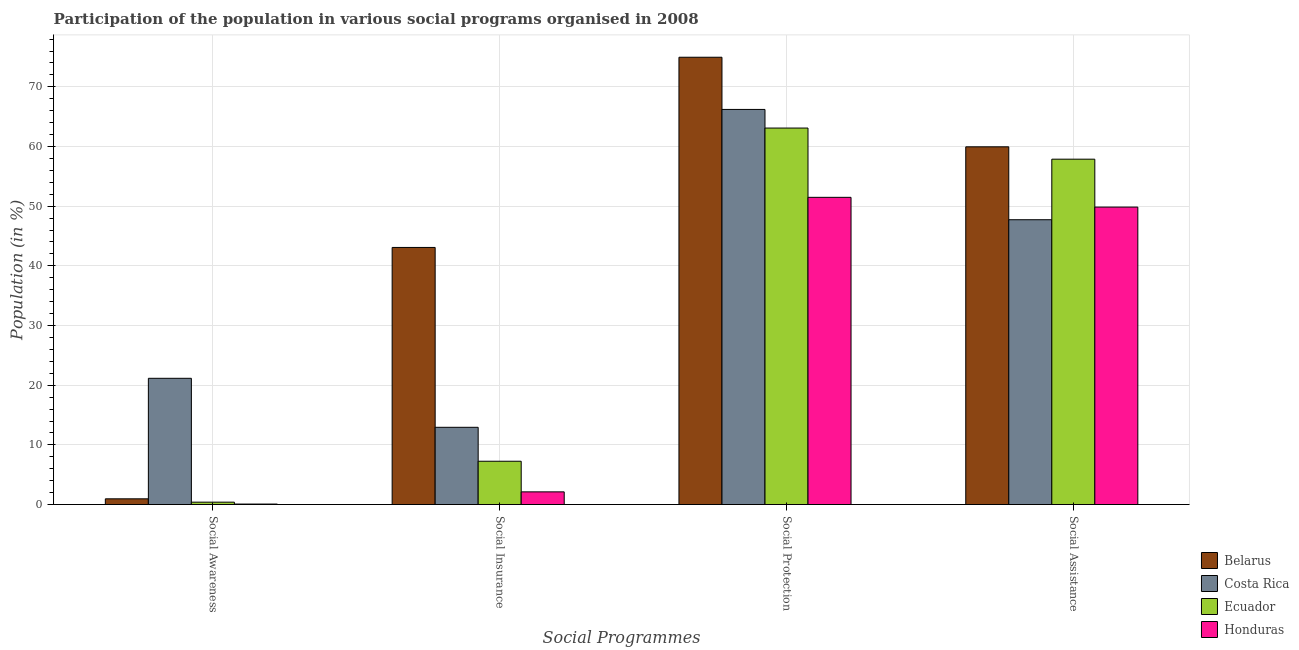Are the number of bars per tick equal to the number of legend labels?
Give a very brief answer. Yes. What is the label of the 3rd group of bars from the left?
Provide a succinct answer. Social Protection. What is the participation of population in social protection programs in Costa Rica?
Give a very brief answer. 66.22. Across all countries, what is the maximum participation of population in social assistance programs?
Your answer should be compact. 59.95. Across all countries, what is the minimum participation of population in social awareness programs?
Make the answer very short. 0.08. In which country was the participation of population in social awareness programs maximum?
Your answer should be compact. Costa Rica. What is the total participation of population in social awareness programs in the graph?
Make the answer very short. 22.59. What is the difference between the participation of population in social assistance programs in Belarus and that in Costa Rica?
Offer a very short reply. 12.22. What is the difference between the participation of population in social protection programs in Ecuador and the participation of population in social insurance programs in Honduras?
Ensure brevity in your answer.  60.97. What is the average participation of population in social protection programs per country?
Offer a terse response. 63.94. What is the difference between the participation of population in social awareness programs and participation of population in social insurance programs in Costa Rica?
Provide a succinct answer. 8.21. In how many countries, is the participation of population in social assistance programs greater than 30 %?
Ensure brevity in your answer.  4. What is the ratio of the participation of population in social insurance programs in Belarus to that in Costa Rica?
Your answer should be compact. 3.33. Is the difference between the participation of population in social protection programs in Ecuador and Costa Rica greater than the difference between the participation of population in social insurance programs in Ecuador and Costa Rica?
Provide a short and direct response. Yes. What is the difference between the highest and the second highest participation of population in social assistance programs?
Your answer should be compact. 2.07. What is the difference between the highest and the lowest participation of population in social insurance programs?
Ensure brevity in your answer.  40.96. In how many countries, is the participation of population in social awareness programs greater than the average participation of population in social awareness programs taken over all countries?
Offer a very short reply. 1. Is it the case that in every country, the sum of the participation of population in social assistance programs and participation of population in social insurance programs is greater than the sum of participation of population in social awareness programs and participation of population in social protection programs?
Give a very brief answer. Yes. What does the 1st bar from the left in Social Protection represents?
Provide a short and direct response. Belarus. What does the 4th bar from the right in Social Insurance represents?
Your answer should be very brief. Belarus. How many bars are there?
Offer a terse response. 16. Are all the bars in the graph horizontal?
Your answer should be very brief. No. What is the difference between two consecutive major ticks on the Y-axis?
Offer a very short reply. 10. Where does the legend appear in the graph?
Offer a very short reply. Bottom right. How many legend labels are there?
Your answer should be very brief. 4. What is the title of the graph?
Provide a short and direct response. Participation of the population in various social programs organised in 2008. Does "Central Europe" appear as one of the legend labels in the graph?
Give a very brief answer. No. What is the label or title of the X-axis?
Your response must be concise. Social Programmes. What is the Population (in %) of Belarus in Social Awareness?
Provide a short and direct response. 0.96. What is the Population (in %) in Costa Rica in Social Awareness?
Make the answer very short. 21.15. What is the Population (in %) in Ecuador in Social Awareness?
Ensure brevity in your answer.  0.4. What is the Population (in %) in Honduras in Social Awareness?
Your answer should be very brief. 0.08. What is the Population (in %) in Belarus in Social Insurance?
Your answer should be very brief. 43.09. What is the Population (in %) of Costa Rica in Social Insurance?
Provide a short and direct response. 12.94. What is the Population (in %) in Ecuador in Social Insurance?
Provide a succinct answer. 7.26. What is the Population (in %) of Honduras in Social Insurance?
Keep it short and to the point. 2.12. What is the Population (in %) of Belarus in Social Protection?
Offer a very short reply. 74.96. What is the Population (in %) in Costa Rica in Social Protection?
Your answer should be very brief. 66.22. What is the Population (in %) of Ecuador in Social Protection?
Provide a short and direct response. 63.09. What is the Population (in %) of Honduras in Social Protection?
Offer a very short reply. 51.48. What is the Population (in %) in Belarus in Social Assistance?
Provide a short and direct response. 59.95. What is the Population (in %) in Costa Rica in Social Assistance?
Make the answer very short. 47.73. What is the Population (in %) of Ecuador in Social Assistance?
Your answer should be compact. 57.88. What is the Population (in %) in Honduras in Social Assistance?
Offer a terse response. 49.85. Across all Social Programmes, what is the maximum Population (in %) of Belarus?
Provide a succinct answer. 74.96. Across all Social Programmes, what is the maximum Population (in %) of Costa Rica?
Your answer should be compact. 66.22. Across all Social Programmes, what is the maximum Population (in %) in Ecuador?
Make the answer very short. 63.09. Across all Social Programmes, what is the maximum Population (in %) in Honduras?
Your answer should be very brief. 51.48. Across all Social Programmes, what is the minimum Population (in %) of Belarus?
Ensure brevity in your answer.  0.96. Across all Social Programmes, what is the minimum Population (in %) of Costa Rica?
Give a very brief answer. 12.94. Across all Social Programmes, what is the minimum Population (in %) in Ecuador?
Ensure brevity in your answer.  0.4. Across all Social Programmes, what is the minimum Population (in %) of Honduras?
Provide a short and direct response. 0.08. What is the total Population (in %) in Belarus in the graph?
Your answer should be very brief. 178.95. What is the total Population (in %) of Costa Rica in the graph?
Your answer should be very brief. 148.05. What is the total Population (in %) in Ecuador in the graph?
Ensure brevity in your answer.  128.62. What is the total Population (in %) of Honduras in the graph?
Your response must be concise. 103.54. What is the difference between the Population (in %) of Belarus in Social Awareness and that in Social Insurance?
Make the answer very short. -42.13. What is the difference between the Population (in %) of Costa Rica in Social Awareness and that in Social Insurance?
Your answer should be compact. 8.21. What is the difference between the Population (in %) in Ecuador in Social Awareness and that in Social Insurance?
Your response must be concise. -6.86. What is the difference between the Population (in %) of Honduras in Social Awareness and that in Social Insurance?
Offer a terse response. -2.04. What is the difference between the Population (in %) in Belarus in Social Awareness and that in Social Protection?
Offer a terse response. -74. What is the difference between the Population (in %) in Costa Rica in Social Awareness and that in Social Protection?
Your response must be concise. -45.06. What is the difference between the Population (in %) of Ecuador in Social Awareness and that in Social Protection?
Make the answer very short. -62.7. What is the difference between the Population (in %) of Honduras in Social Awareness and that in Social Protection?
Provide a short and direct response. -51.4. What is the difference between the Population (in %) in Belarus in Social Awareness and that in Social Assistance?
Your response must be concise. -58.99. What is the difference between the Population (in %) of Costa Rica in Social Awareness and that in Social Assistance?
Ensure brevity in your answer.  -26.58. What is the difference between the Population (in %) in Ecuador in Social Awareness and that in Social Assistance?
Offer a very short reply. -57.48. What is the difference between the Population (in %) of Honduras in Social Awareness and that in Social Assistance?
Make the answer very short. -49.77. What is the difference between the Population (in %) in Belarus in Social Insurance and that in Social Protection?
Your answer should be very brief. -31.88. What is the difference between the Population (in %) of Costa Rica in Social Insurance and that in Social Protection?
Provide a succinct answer. -53.27. What is the difference between the Population (in %) in Ecuador in Social Insurance and that in Social Protection?
Ensure brevity in your answer.  -55.84. What is the difference between the Population (in %) of Honduras in Social Insurance and that in Social Protection?
Offer a terse response. -49.36. What is the difference between the Population (in %) of Belarus in Social Insurance and that in Social Assistance?
Offer a very short reply. -16.86. What is the difference between the Population (in %) in Costa Rica in Social Insurance and that in Social Assistance?
Provide a succinct answer. -34.79. What is the difference between the Population (in %) in Ecuador in Social Insurance and that in Social Assistance?
Provide a short and direct response. -50.62. What is the difference between the Population (in %) of Honduras in Social Insurance and that in Social Assistance?
Provide a short and direct response. -47.72. What is the difference between the Population (in %) of Belarus in Social Protection and that in Social Assistance?
Give a very brief answer. 15.01. What is the difference between the Population (in %) of Costa Rica in Social Protection and that in Social Assistance?
Your response must be concise. 18.48. What is the difference between the Population (in %) in Ecuador in Social Protection and that in Social Assistance?
Your response must be concise. 5.22. What is the difference between the Population (in %) of Honduras in Social Protection and that in Social Assistance?
Offer a very short reply. 1.63. What is the difference between the Population (in %) in Belarus in Social Awareness and the Population (in %) in Costa Rica in Social Insurance?
Offer a terse response. -11.99. What is the difference between the Population (in %) of Belarus in Social Awareness and the Population (in %) of Ecuador in Social Insurance?
Make the answer very short. -6.3. What is the difference between the Population (in %) of Belarus in Social Awareness and the Population (in %) of Honduras in Social Insurance?
Offer a very short reply. -1.17. What is the difference between the Population (in %) of Costa Rica in Social Awareness and the Population (in %) of Ecuador in Social Insurance?
Ensure brevity in your answer.  13.9. What is the difference between the Population (in %) in Costa Rica in Social Awareness and the Population (in %) in Honduras in Social Insurance?
Make the answer very short. 19.03. What is the difference between the Population (in %) of Ecuador in Social Awareness and the Population (in %) of Honduras in Social Insurance?
Provide a succinct answer. -1.73. What is the difference between the Population (in %) of Belarus in Social Awareness and the Population (in %) of Costa Rica in Social Protection?
Your answer should be compact. -65.26. What is the difference between the Population (in %) in Belarus in Social Awareness and the Population (in %) in Ecuador in Social Protection?
Your answer should be compact. -62.14. What is the difference between the Population (in %) of Belarus in Social Awareness and the Population (in %) of Honduras in Social Protection?
Provide a succinct answer. -50.52. What is the difference between the Population (in %) of Costa Rica in Social Awareness and the Population (in %) of Ecuador in Social Protection?
Provide a short and direct response. -41.94. What is the difference between the Population (in %) in Costa Rica in Social Awareness and the Population (in %) in Honduras in Social Protection?
Make the answer very short. -30.33. What is the difference between the Population (in %) of Ecuador in Social Awareness and the Population (in %) of Honduras in Social Protection?
Ensure brevity in your answer.  -51.08. What is the difference between the Population (in %) of Belarus in Social Awareness and the Population (in %) of Costa Rica in Social Assistance?
Make the answer very short. -46.77. What is the difference between the Population (in %) of Belarus in Social Awareness and the Population (in %) of Ecuador in Social Assistance?
Give a very brief answer. -56.92. What is the difference between the Population (in %) of Belarus in Social Awareness and the Population (in %) of Honduras in Social Assistance?
Offer a very short reply. -48.89. What is the difference between the Population (in %) in Costa Rica in Social Awareness and the Population (in %) in Ecuador in Social Assistance?
Provide a short and direct response. -36.72. What is the difference between the Population (in %) in Costa Rica in Social Awareness and the Population (in %) in Honduras in Social Assistance?
Your answer should be compact. -28.69. What is the difference between the Population (in %) of Ecuador in Social Awareness and the Population (in %) of Honduras in Social Assistance?
Give a very brief answer. -49.45. What is the difference between the Population (in %) of Belarus in Social Insurance and the Population (in %) of Costa Rica in Social Protection?
Keep it short and to the point. -23.13. What is the difference between the Population (in %) of Belarus in Social Insurance and the Population (in %) of Ecuador in Social Protection?
Your response must be concise. -20.01. What is the difference between the Population (in %) in Belarus in Social Insurance and the Population (in %) in Honduras in Social Protection?
Your response must be concise. -8.4. What is the difference between the Population (in %) in Costa Rica in Social Insurance and the Population (in %) in Ecuador in Social Protection?
Give a very brief answer. -50.15. What is the difference between the Population (in %) in Costa Rica in Social Insurance and the Population (in %) in Honduras in Social Protection?
Give a very brief answer. -38.54. What is the difference between the Population (in %) of Ecuador in Social Insurance and the Population (in %) of Honduras in Social Protection?
Give a very brief answer. -44.23. What is the difference between the Population (in %) in Belarus in Social Insurance and the Population (in %) in Costa Rica in Social Assistance?
Give a very brief answer. -4.65. What is the difference between the Population (in %) of Belarus in Social Insurance and the Population (in %) of Ecuador in Social Assistance?
Your response must be concise. -14.79. What is the difference between the Population (in %) in Belarus in Social Insurance and the Population (in %) in Honduras in Social Assistance?
Your answer should be very brief. -6.76. What is the difference between the Population (in %) in Costa Rica in Social Insurance and the Population (in %) in Ecuador in Social Assistance?
Your answer should be compact. -44.93. What is the difference between the Population (in %) of Costa Rica in Social Insurance and the Population (in %) of Honduras in Social Assistance?
Provide a succinct answer. -36.9. What is the difference between the Population (in %) in Ecuador in Social Insurance and the Population (in %) in Honduras in Social Assistance?
Make the answer very short. -42.59. What is the difference between the Population (in %) in Belarus in Social Protection and the Population (in %) in Costa Rica in Social Assistance?
Make the answer very short. 27.23. What is the difference between the Population (in %) of Belarus in Social Protection and the Population (in %) of Ecuador in Social Assistance?
Your answer should be compact. 17.08. What is the difference between the Population (in %) in Belarus in Social Protection and the Population (in %) in Honduras in Social Assistance?
Your response must be concise. 25.11. What is the difference between the Population (in %) in Costa Rica in Social Protection and the Population (in %) in Ecuador in Social Assistance?
Give a very brief answer. 8.34. What is the difference between the Population (in %) of Costa Rica in Social Protection and the Population (in %) of Honduras in Social Assistance?
Your answer should be compact. 16.37. What is the difference between the Population (in %) of Ecuador in Social Protection and the Population (in %) of Honduras in Social Assistance?
Offer a terse response. 13.24. What is the average Population (in %) in Belarus per Social Programmes?
Offer a very short reply. 44.74. What is the average Population (in %) of Costa Rica per Social Programmes?
Provide a succinct answer. 37.01. What is the average Population (in %) in Ecuador per Social Programmes?
Your response must be concise. 32.16. What is the average Population (in %) of Honduras per Social Programmes?
Your answer should be very brief. 25.88. What is the difference between the Population (in %) in Belarus and Population (in %) in Costa Rica in Social Awareness?
Your response must be concise. -20.2. What is the difference between the Population (in %) in Belarus and Population (in %) in Ecuador in Social Awareness?
Your answer should be very brief. 0.56. What is the difference between the Population (in %) of Belarus and Population (in %) of Honduras in Social Awareness?
Provide a short and direct response. 0.88. What is the difference between the Population (in %) in Costa Rica and Population (in %) in Ecuador in Social Awareness?
Offer a terse response. 20.76. What is the difference between the Population (in %) in Costa Rica and Population (in %) in Honduras in Social Awareness?
Your answer should be compact. 21.07. What is the difference between the Population (in %) of Ecuador and Population (in %) of Honduras in Social Awareness?
Make the answer very short. 0.32. What is the difference between the Population (in %) in Belarus and Population (in %) in Costa Rica in Social Insurance?
Ensure brevity in your answer.  30.14. What is the difference between the Population (in %) in Belarus and Population (in %) in Ecuador in Social Insurance?
Offer a very short reply. 35.83. What is the difference between the Population (in %) in Belarus and Population (in %) in Honduras in Social Insurance?
Offer a terse response. 40.96. What is the difference between the Population (in %) in Costa Rica and Population (in %) in Ecuador in Social Insurance?
Provide a succinct answer. 5.69. What is the difference between the Population (in %) of Costa Rica and Population (in %) of Honduras in Social Insurance?
Provide a succinct answer. 10.82. What is the difference between the Population (in %) in Ecuador and Population (in %) in Honduras in Social Insurance?
Ensure brevity in your answer.  5.13. What is the difference between the Population (in %) in Belarus and Population (in %) in Costa Rica in Social Protection?
Provide a short and direct response. 8.75. What is the difference between the Population (in %) in Belarus and Population (in %) in Ecuador in Social Protection?
Provide a succinct answer. 11.87. What is the difference between the Population (in %) in Belarus and Population (in %) in Honduras in Social Protection?
Your answer should be compact. 23.48. What is the difference between the Population (in %) in Costa Rica and Population (in %) in Ecuador in Social Protection?
Keep it short and to the point. 3.12. What is the difference between the Population (in %) in Costa Rica and Population (in %) in Honduras in Social Protection?
Your answer should be compact. 14.73. What is the difference between the Population (in %) in Ecuador and Population (in %) in Honduras in Social Protection?
Make the answer very short. 11.61. What is the difference between the Population (in %) of Belarus and Population (in %) of Costa Rica in Social Assistance?
Your answer should be compact. 12.22. What is the difference between the Population (in %) in Belarus and Population (in %) in Ecuador in Social Assistance?
Provide a short and direct response. 2.07. What is the difference between the Population (in %) in Belarus and Population (in %) in Honduras in Social Assistance?
Ensure brevity in your answer.  10.1. What is the difference between the Population (in %) in Costa Rica and Population (in %) in Ecuador in Social Assistance?
Provide a short and direct response. -10.14. What is the difference between the Population (in %) of Costa Rica and Population (in %) of Honduras in Social Assistance?
Provide a short and direct response. -2.12. What is the difference between the Population (in %) of Ecuador and Population (in %) of Honduras in Social Assistance?
Your response must be concise. 8.03. What is the ratio of the Population (in %) in Belarus in Social Awareness to that in Social Insurance?
Your answer should be compact. 0.02. What is the ratio of the Population (in %) in Costa Rica in Social Awareness to that in Social Insurance?
Your answer should be very brief. 1.63. What is the ratio of the Population (in %) in Ecuador in Social Awareness to that in Social Insurance?
Offer a terse response. 0.05. What is the ratio of the Population (in %) in Honduras in Social Awareness to that in Social Insurance?
Make the answer very short. 0.04. What is the ratio of the Population (in %) of Belarus in Social Awareness to that in Social Protection?
Ensure brevity in your answer.  0.01. What is the ratio of the Population (in %) in Costa Rica in Social Awareness to that in Social Protection?
Your answer should be very brief. 0.32. What is the ratio of the Population (in %) in Ecuador in Social Awareness to that in Social Protection?
Make the answer very short. 0.01. What is the ratio of the Population (in %) in Honduras in Social Awareness to that in Social Protection?
Provide a succinct answer. 0. What is the ratio of the Population (in %) of Belarus in Social Awareness to that in Social Assistance?
Your answer should be very brief. 0.02. What is the ratio of the Population (in %) of Costa Rica in Social Awareness to that in Social Assistance?
Your response must be concise. 0.44. What is the ratio of the Population (in %) in Ecuador in Social Awareness to that in Social Assistance?
Ensure brevity in your answer.  0.01. What is the ratio of the Population (in %) in Honduras in Social Awareness to that in Social Assistance?
Keep it short and to the point. 0. What is the ratio of the Population (in %) of Belarus in Social Insurance to that in Social Protection?
Give a very brief answer. 0.57. What is the ratio of the Population (in %) of Costa Rica in Social Insurance to that in Social Protection?
Your answer should be compact. 0.2. What is the ratio of the Population (in %) of Ecuador in Social Insurance to that in Social Protection?
Offer a terse response. 0.12. What is the ratio of the Population (in %) of Honduras in Social Insurance to that in Social Protection?
Your answer should be compact. 0.04. What is the ratio of the Population (in %) of Belarus in Social Insurance to that in Social Assistance?
Keep it short and to the point. 0.72. What is the ratio of the Population (in %) in Costa Rica in Social Insurance to that in Social Assistance?
Your answer should be very brief. 0.27. What is the ratio of the Population (in %) in Ecuador in Social Insurance to that in Social Assistance?
Make the answer very short. 0.13. What is the ratio of the Population (in %) in Honduras in Social Insurance to that in Social Assistance?
Offer a very short reply. 0.04. What is the ratio of the Population (in %) in Belarus in Social Protection to that in Social Assistance?
Your answer should be very brief. 1.25. What is the ratio of the Population (in %) of Costa Rica in Social Protection to that in Social Assistance?
Keep it short and to the point. 1.39. What is the ratio of the Population (in %) of Ecuador in Social Protection to that in Social Assistance?
Offer a very short reply. 1.09. What is the ratio of the Population (in %) of Honduras in Social Protection to that in Social Assistance?
Provide a short and direct response. 1.03. What is the difference between the highest and the second highest Population (in %) of Belarus?
Your answer should be compact. 15.01. What is the difference between the highest and the second highest Population (in %) in Costa Rica?
Give a very brief answer. 18.48. What is the difference between the highest and the second highest Population (in %) of Ecuador?
Offer a terse response. 5.22. What is the difference between the highest and the second highest Population (in %) in Honduras?
Provide a short and direct response. 1.63. What is the difference between the highest and the lowest Population (in %) in Belarus?
Keep it short and to the point. 74. What is the difference between the highest and the lowest Population (in %) in Costa Rica?
Give a very brief answer. 53.27. What is the difference between the highest and the lowest Population (in %) of Ecuador?
Your response must be concise. 62.7. What is the difference between the highest and the lowest Population (in %) in Honduras?
Offer a very short reply. 51.4. 